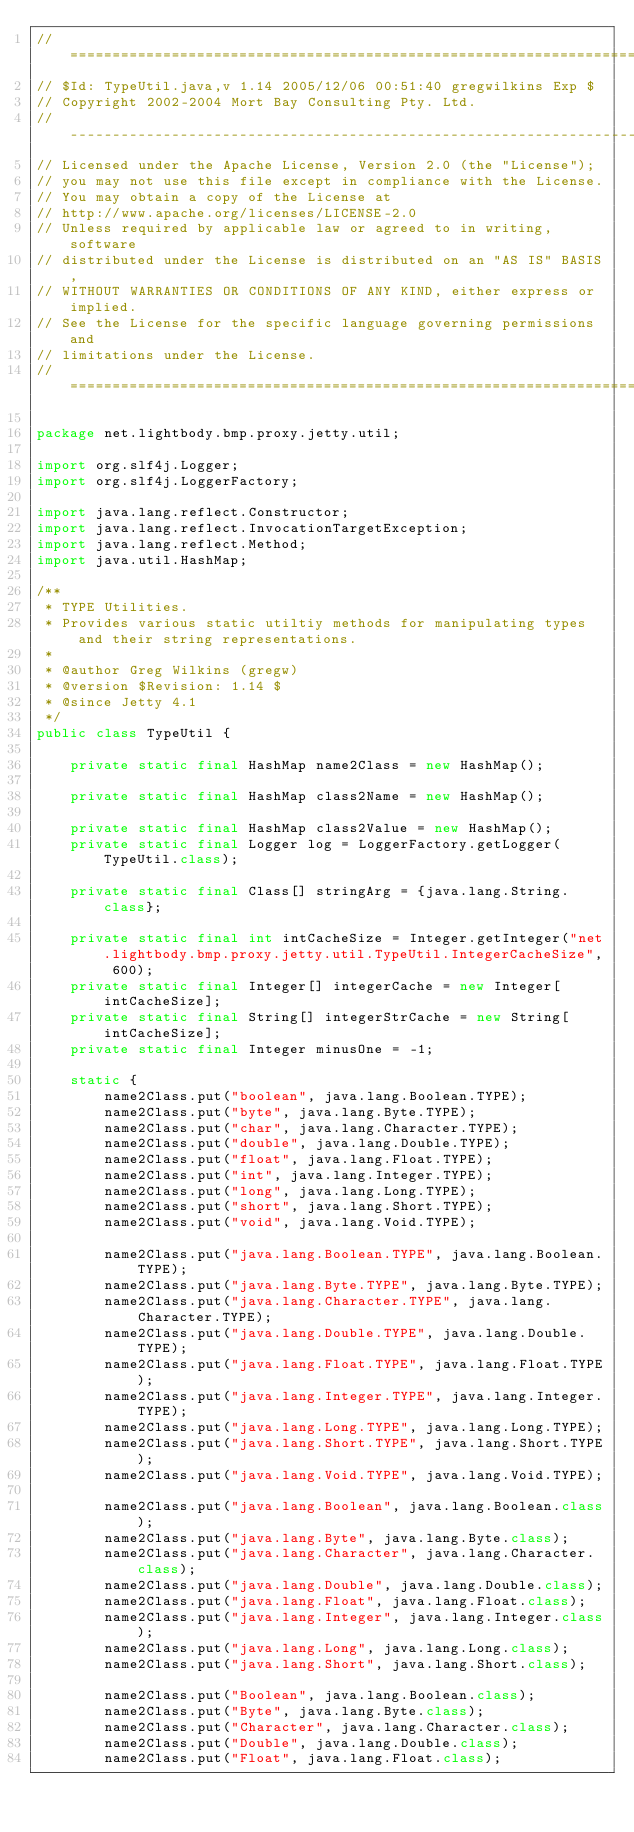Convert code to text. <code><loc_0><loc_0><loc_500><loc_500><_Java_>// ========================================================================
// $Id: TypeUtil.java,v 1.14 2005/12/06 00:51:40 gregwilkins Exp $
// Copyright 2002-2004 Mort Bay Consulting Pty. Ltd.
// ------------------------------------------------------------------------
// Licensed under the Apache License, Version 2.0 (the "License");
// you may not use this file except in compliance with the License.
// You may obtain a copy of the License at 
// http://www.apache.org/licenses/LICENSE-2.0
// Unless required by applicable law or agreed to in writing, software
// distributed under the License is distributed on an "AS IS" BASIS,
// WITHOUT WARRANTIES OR CONDITIONS OF ANY KIND, either express or implied.
// See the License for the specific language governing permissions and
// limitations under the License.
// ========================================================================

package net.lightbody.bmp.proxy.jetty.util;

import org.slf4j.Logger;
import org.slf4j.LoggerFactory;

import java.lang.reflect.Constructor;
import java.lang.reflect.InvocationTargetException;
import java.lang.reflect.Method;
import java.util.HashMap;

/**
 * TYPE Utilities.
 * Provides various static utiltiy methods for manipulating types and their string representations.
 *
 * @author Greg Wilkins (gregw)
 * @version $Revision: 1.14 $
 * @since Jetty 4.1
 */
public class TypeUtil {
    
    private static final HashMap name2Class = new HashMap();
    
    private static final HashMap class2Name = new HashMap();
    
    private static final HashMap class2Value = new HashMap();
    private static final Logger log = LoggerFactory.getLogger(TypeUtil.class);
    
    private static final Class[] stringArg = {java.lang.String.class};
    
    private static final int intCacheSize = Integer.getInteger("net.lightbody.bmp.proxy.jetty.util.TypeUtil.IntegerCacheSize", 600);
    private static final Integer[] integerCache = new Integer[intCacheSize];
    private static final String[] integerStrCache = new String[intCacheSize];
    private static final Integer minusOne = -1;

    static {
        name2Class.put("boolean", java.lang.Boolean.TYPE);
        name2Class.put("byte", java.lang.Byte.TYPE);
        name2Class.put("char", java.lang.Character.TYPE);
        name2Class.put("double", java.lang.Double.TYPE);
        name2Class.put("float", java.lang.Float.TYPE);
        name2Class.put("int", java.lang.Integer.TYPE);
        name2Class.put("long", java.lang.Long.TYPE);
        name2Class.put("short", java.lang.Short.TYPE);
        name2Class.put("void", java.lang.Void.TYPE);

        name2Class.put("java.lang.Boolean.TYPE", java.lang.Boolean.TYPE);
        name2Class.put("java.lang.Byte.TYPE", java.lang.Byte.TYPE);
        name2Class.put("java.lang.Character.TYPE", java.lang.Character.TYPE);
        name2Class.put("java.lang.Double.TYPE", java.lang.Double.TYPE);
        name2Class.put("java.lang.Float.TYPE", java.lang.Float.TYPE);
        name2Class.put("java.lang.Integer.TYPE", java.lang.Integer.TYPE);
        name2Class.put("java.lang.Long.TYPE", java.lang.Long.TYPE);
        name2Class.put("java.lang.Short.TYPE", java.lang.Short.TYPE);
        name2Class.put("java.lang.Void.TYPE", java.lang.Void.TYPE);

        name2Class.put("java.lang.Boolean", java.lang.Boolean.class);
        name2Class.put("java.lang.Byte", java.lang.Byte.class);
        name2Class.put("java.lang.Character", java.lang.Character.class);
        name2Class.put("java.lang.Double", java.lang.Double.class);
        name2Class.put("java.lang.Float", java.lang.Float.class);
        name2Class.put("java.lang.Integer", java.lang.Integer.class);
        name2Class.put("java.lang.Long", java.lang.Long.class);
        name2Class.put("java.lang.Short", java.lang.Short.class);

        name2Class.put("Boolean", java.lang.Boolean.class);
        name2Class.put("Byte", java.lang.Byte.class);
        name2Class.put("Character", java.lang.Character.class);
        name2Class.put("Double", java.lang.Double.class);
        name2Class.put("Float", java.lang.Float.class);</code> 